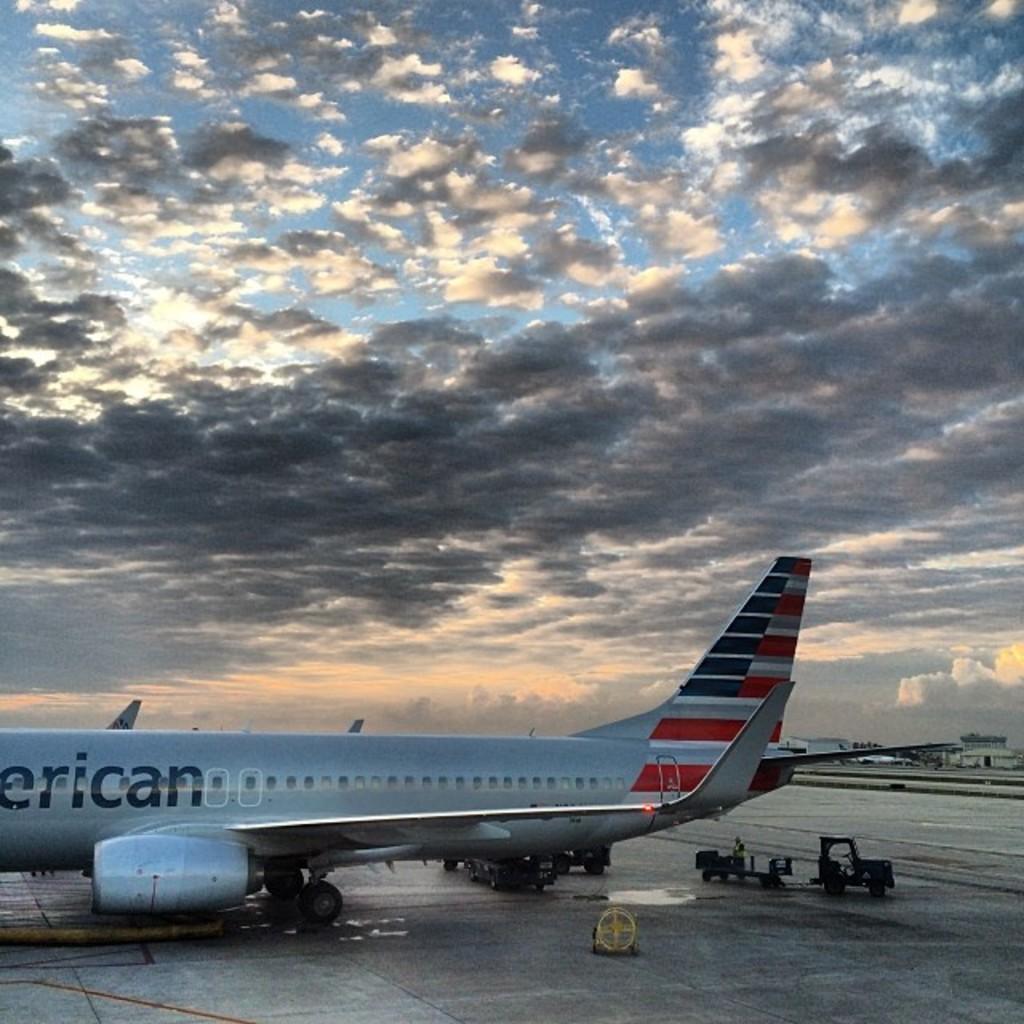Can you describe this image briefly? In this image we can see an aeroplane on the runway. On the right side of the image there is a luggage carrier. In the background there is a building, sky and clouds. 